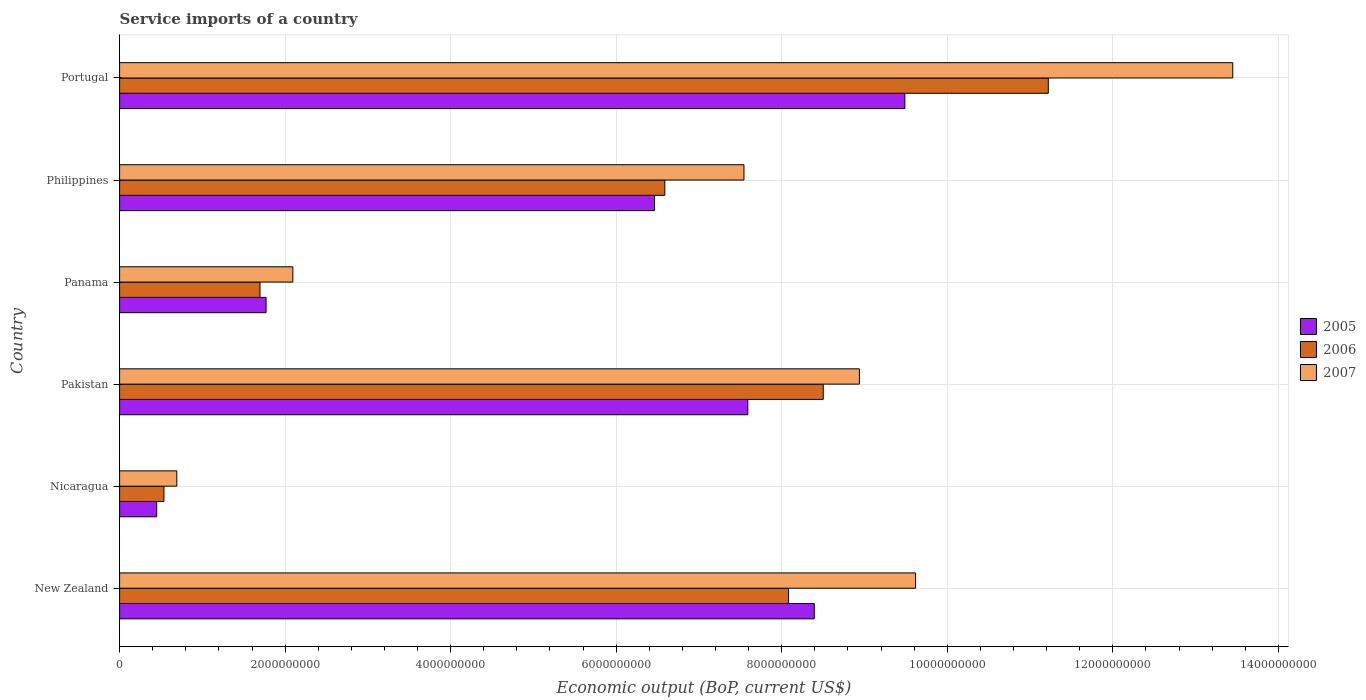How many different coloured bars are there?
Provide a short and direct response. 3. Are the number of bars per tick equal to the number of legend labels?
Make the answer very short. Yes. How many bars are there on the 1st tick from the bottom?
Give a very brief answer. 3. What is the label of the 4th group of bars from the top?
Offer a terse response. Pakistan. What is the service imports in 2006 in New Zealand?
Offer a terse response. 8.08e+09. Across all countries, what is the maximum service imports in 2006?
Provide a succinct answer. 1.12e+1. Across all countries, what is the minimum service imports in 2005?
Offer a terse response. 4.48e+08. In which country was the service imports in 2007 maximum?
Provide a short and direct response. Portugal. In which country was the service imports in 2005 minimum?
Ensure brevity in your answer.  Nicaragua. What is the total service imports in 2007 in the graph?
Keep it short and to the point. 4.23e+1. What is the difference between the service imports in 2007 in Nicaragua and that in Philippines?
Offer a terse response. -6.85e+09. What is the difference between the service imports in 2005 in New Zealand and the service imports in 2006 in Philippines?
Your response must be concise. 1.81e+09. What is the average service imports in 2005 per country?
Your response must be concise. 5.69e+09. What is the difference between the service imports in 2006 and service imports in 2007 in Pakistan?
Keep it short and to the point. -4.37e+08. In how many countries, is the service imports in 2007 greater than 7600000000 US$?
Give a very brief answer. 3. What is the ratio of the service imports in 2007 in Nicaragua to that in Philippines?
Your answer should be very brief. 0.09. Is the difference between the service imports in 2006 in Pakistan and Panama greater than the difference between the service imports in 2007 in Pakistan and Panama?
Your response must be concise. No. What is the difference between the highest and the second highest service imports in 2006?
Make the answer very short. 2.72e+09. What is the difference between the highest and the lowest service imports in 2006?
Offer a very short reply. 1.07e+1. In how many countries, is the service imports in 2007 greater than the average service imports in 2007 taken over all countries?
Your response must be concise. 4. Is the sum of the service imports in 2006 in Nicaragua and Philippines greater than the maximum service imports in 2007 across all countries?
Offer a very short reply. No. What does the 2nd bar from the top in Panama represents?
Keep it short and to the point. 2006. What does the 2nd bar from the bottom in New Zealand represents?
Make the answer very short. 2006. Is it the case that in every country, the sum of the service imports in 2006 and service imports in 2005 is greater than the service imports in 2007?
Provide a short and direct response. Yes. How many bars are there?
Provide a short and direct response. 18. Are all the bars in the graph horizontal?
Your response must be concise. Yes. What is the difference between two consecutive major ticks on the X-axis?
Your answer should be very brief. 2.00e+09. Are the values on the major ticks of X-axis written in scientific E-notation?
Your response must be concise. No. Does the graph contain any zero values?
Make the answer very short. No. How are the legend labels stacked?
Give a very brief answer. Vertical. What is the title of the graph?
Keep it short and to the point. Service imports of a country. Does "2008" appear as one of the legend labels in the graph?
Your answer should be very brief. No. What is the label or title of the X-axis?
Offer a very short reply. Economic output (BoP, current US$). What is the label or title of the Y-axis?
Your response must be concise. Country. What is the Economic output (BoP, current US$) in 2005 in New Zealand?
Your response must be concise. 8.39e+09. What is the Economic output (BoP, current US$) of 2006 in New Zealand?
Give a very brief answer. 8.08e+09. What is the Economic output (BoP, current US$) in 2007 in New Zealand?
Your answer should be very brief. 9.62e+09. What is the Economic output (BoP, current US$) in 2005 in Nicaragua?
Provide a succinct answer. 4.48e+08. What is the Economic output (BoP, current US$) in 2006 in Nicaragua?
Your answer should be compact. 5.36e+08. What is the Economic output (BoP, current US$) of 2007 in Nicaragua?
Provide a succinct answer. 6.91e+08. What is the Economic output (BoP, current US$) of 2005 in Pakistan?
Provide a succinct answer. 7.59e+09. What is the Economic output (BoP, current US$) in 2006 in Pakistan?
Ensure brevity in your answer.  8.50e+09. What is the Economic output (BoP, current US$) in 2007 in Pakistan?
Your response must be concise. 8.94e+09. What is the Economic output (BoP, current US$) in 2005 in Panama?
Your answer should be very brief. 1.77e+09. What is the Economic output (BoP, current US$) of 2006 in Panama?
Ensure brevity in your answer.  1.70e+09. What is the Economic output (BoP, current US$) in 2007 in Panama?
Make the answer very short. 2.09e+09. What is the Economic output (BoP, current US$) of 2005 in Philippines?
Your answer should be compact. 6.46e+09. What is the Economic output (BoP, current US$) of 2006 in Philippines?
Give a very brief answer. 6.59e+09. What is the Economic output (BoP, current US$) of 2007 in Philippines?
Provide a short and direct response. 7.54e+09. What is the Economic output (BoP, current US$) in 2005 in Portugal?
Offer a very short reply. 9.49e+09. What is the Economic output (BoP, current US$) of 2006 in Portugal?
Your response must be concise. 1.12e+1. What is the Economic output (BoP, current US$) of 2007 in Portugal?
Provide a succinct answer. 1.34e+1. Across all countries, what is the maximum Economic output (BoP, current US$) of 2005?
Give a very brief answer. 9.49e+09. Across all countries, what is the maximum Economic output (BoP, current US$) of 2006?
Provide a short and direct response. 1.12e+1. Across all countries, what is the maximum Economic output (BoP, current US$) of 2007?
Offer a terse response. 1.34e+1. Across all countries, what is the minimum Economic output (BoP, current US$) in 2005?
Offer a very short reply. 4.48e+08. Across all countries, what is the minimum Economic output (BoP, current US$) of 2006?
Provide a succinct answer. 5.36e+08. Across all countries, what is the minimum Economic output (BoP, current US$) of 2007?
Ensure brevity in your answer.  6.91e+08. What is the total Economic output (BoP, current US$) of 2005 in the graph?
Your answer should be very brief. 3.42e+1. What is the total Economic output (BoP, current US$) in 2006 in the graph?
Your response must be concise. 3.66e+1. What is the total Economic output (BoP, current US$) of 2007 in the graph?
Your answer should be very brief. 4.23e+1. What is the difference between the Economic output (BoP, current US$) in 2005 in New Zealand and that in Nicaragua?
Your answer should be compact. 7.94e+09. What is the difference between the Economic output (BoP, current US$) of 2006 in New Zealand and that in Nicaragua?
Make the answer very short. 7.55e+09. What is the difference between the Economic output (BoP, current US$) in 2007 in New Zealand and that in Nicaragua?
Give a very brief answer. 8.93e+09. What is the difference between the Economic output (BoP, current US$) in 2005 in New Zealand and that in Pakistan?
Your answer should be very brief. 8.03e+08. What is the difference between the Economic output (BoP, current US$) in 2006 in New Zealand and that in Pakistan?
Make the answer very short. -4.19e+08. What is the difference between the Economic output (BoP, current US$) in 2007 in New Zealand and that in Pakistan?
Give a very brief answer. 6.78e+08. What is the difference between the Economic output (BoP, current US$) in 2005 in New Zealand and that in Panama?
Give a very brief answer. 6.62e+09. What is the difference between the Economic output (BoP, current US$) in 2006 in New Zealand and that in Panama?
Offer a very short reply. 6.39e+09. What is the difference between the Economic output (BoP, current US$) in 2007 in New Zealand and that in Panama?
Your answer should be very brief. 7.52e+09. What is the difference between the Economic output (BoP, current US$) of 2005 in New Zealand and that in Philippines?
Offer a very short reply. 1.93e+09. What is the difference between the Economic output (BoP, current US$) of 2006 in New Zealand and that in Philippines?
Make the answer very short. 1.49e+09. What is the difference between the Economic output (BoP, current US$) of 2007 in New Zealand and that in Philippines?
Provide a short and direct response. 2.07e+09. What is the difference between the Economic output (BoP, current US$) in 2005 in New Zealand and that in Portugal?
Provide a short and direct response. -1.09e+09. What is the difference between the Economic output (BoP, current US$) of 2006 in New Zealand and that in Portugal?
Give a very brief answer. -3.14e+09. What is the difference between the Economic output (BoP, current US$) of 2007 in New Zealand and that in Portugal?
Your response must be concise. -3.83e+09. What is the difference between the Economic output (BoP, current US$) of 2005 in Nicaragua and that in Pakistan?
Ensure brevity in your answer.  -7.14e+09. What is the difference between the Economic output (BoP, current US$) of 2006 in Nicaragua and that in Pakistan?
Make the answer very short. -7.97e+09. What is the difference between the Economic output (BoP, current US$) in 2007 in Nicaragua and that in Pakistan?
Offer a very short reply. -8.25e+09. What is the difference between the Economic output (BoP, current US$) in 2005 in Nicaragua and that in Panama?
Provide a short and direct response. -1.32e+09. What is the difference between the Economic output (BoP, current US$) in 2006 in Nicaragua and that in Panama?
Offer a terse response. -1.16e+09. What is the difference between the Economic output (BoP, current US$) in 2007 in Nicaragua and that in Panama?
Make the answer very short. -1.40e+09. What is the difference between the Economic output (BoP, current US$) of 2005 in Nicaragua and that in Philippines?
Your response must be concise. -6.02e+09. What is the difference between the Economic output (BoP, current US$) in 2006 in Nicaragua and that in Philippines?
Your response must be concise. -6.05e+09. What is the difference between the Economic output (BoP, current US$) of 2007 in Nicaragua and that in Philippines?
Make the answer very short. -6.85e+09. What is the difference between the Economic output (BoP, current US$) in 2005 in Nicaragua and that in Portugal?
Your response must be concise. -9.04e+09. What is the difference between the Economic output (BoP, current US$) of 2006 in Nicaragua and that in Portugal?
Make the answer very short. -1.07e+1. What is the difference between the Economic output (BoP, current US$) in 2007 in Nicaragua and that in Portugal?
Offer a very short reply. -1.28e+1. What is the difference between the Economic output (BoP, current US$) of 2005 in Pakistan and that in Panama?
Your answer should be very brief. 5.82e+09. What is the difference between the Economic output (BoP, current US$) in 2006 in Pakistan and that in Panama?
Offer a terse response. 6.81e+09. What is the difference between the Economic output (BoP, current US$) in 2007 in Pakistan and that in Panama?
Provide a short and direct response. 6.85e+09. What is the difference between the Economic output (BoP, current US$) in 2005 in Pakistan and that in Philippines?
Ensure brevity in your answer.  1.13e+09. What is the difference between the Economic output (BoP, current US$) in 2006 in Pakistan and that in Philippines?
Your response must be concise. 1.91e+09. What is the difference between the Economic output (BoP, current US$) of 2007 in Pakistan and that in Philippines?
Provide a succinct answer. 1.40e+09. What is the difference between the Economic output (BoP, current US$) in 2005 in Pakistan and that in Portugal?
Ensure brevity in your answer.  -1.90e+09. What is the difference between the Economic output (BoP, current US$) in 2006 in Pakistan and that in Portugal?
Give a very brief answer. -2.72e+09. What is the difference between the Economic output (BoP, current US$) in 2007 in Pakistan and that in Portugal?
Give a very brief answer. -4.51e+09. What is the difference between the Economic output (BoP, current US$) of 2005 in Panama and that in Philippines?
Keep it short and to the point. -4.69e+09. What is the difference between the Economic output (BoP, current US$) in 2006 in Panama and that in Philippines?
Give a very brief answer. -4.89e+09. What is the difference between the Economic output (BoP, current US$) of 2007 in Panama and that in Philippines?
Give a very brief answer. -5.45e+09. What is the difference between the Economic output (BoP, current US$) in 2005 in Panama and that in Portugal?
Offer a terse response. -7.72e+09. What is the difference between the Economic output (BoP, current US$) in 2006 in Panama and that in Portugal?
Ensure brevity in your answer.  -9.52e+09. What is the difference between the Economic output (BoP, current US$) in 2007 in Panama and that in Portugal?
Your answer should be very brief. -1.14e+1. What is the difference between the Economic output (BoP, current US$) of 2005 in Philippines and that in Portugal?
Your response must be concise. -3.02e+09. What is the difference between the Economic output (BoP, current US$) in 2006 in Philippines and that in Portugal?
Provide a short and direct response. -4.63e+09. What is the difference between the Economic output (BoP, current US$) of 2007 in Philippines and that in Portugal?
Ensure brevity in your answer.  -5.91e+09. What is the difference between the Economic output (BoP, current US$) in 2005 in New Zealand and the Economic output (BoP, current US$) in 2006 in Nicaragua?
Offer a very short reply. 7.86e+09. What is the difference between the Economic output (BoP, current US$) in 2005 in New Zealand and the Economic output (BoP, current US$) in 2007 in Nicaragua?
Provide a short and direct response. 7.70e+09. What is the difference between the Economic output (BoP, current US$) of 2006 in New Zealand and the Economic output (BoP, current US$) of 2007 in Nicaragua?
Offer a very short reply. 7.39e+09. What is the difference between the Economic output (BoP, current US$) of 2005 in New Zealand and the Economic output (BoP, current US$) of 2006 in Pakistan?
Your answer should be very brief. -1.09e+08. What is the difference between the Economic output (BoP, current US$) in 2005 in New Zealand and the Economic output (BoP, current US$) in 2007 in Pakistan?
Your response must be concise. -5.46e+08. What is the difference between the Economic output (BoP, current US$) in 2006 in New Zealand and the Economic output (BoP, current US$) in 2007 in Pakistan?
Offer a terse response. -8.56e+08. What is the difference between the Economic output (BoP, current US$) of 2005 in New Zealand and the Economic output (BoP, current US$) of 2006 in Panama?
Provide a short and direct response. 6.70e+09. What is the difference between the Economic output (BoP, current US$) in 2005 in New Zealand and the Economic output (BoP, current US$) in 2007 in Panama?
Provide a succinct answer. 6.30e+09. What is the difference between the Economic output (BoP, current US$) of 2006 in New Zealand and the Economic output (BoP, current US$) of 2007 in Panama?
Keep it short and to the point. 5.99e+09. What is the difference between the Economic output (BoP, current US$) in 2005 in New Zealand and the Economic output (BoP, current US$) in 2006 in Philippines?
Your response must be concise. 1.81e+09. What is the difference between the Economic output (BoP, current US$) in 2005 in New Zealand and the Economic output (BoP, current US$) in 2007 in Philippines?
Your answer should be compact. 8.49e+08. What is the difference between the Economic output (BoP, current US$) of 2006 in New Zealand and the Economic output (BoP, current US$) of 2007 in Philippines?
Keep it short and to the point. 5.39e+08. What is the difference between the Economic output (BoP, current US$) in 2005 in New Zealand and the Economic output (BoP, current US$) in 2006 in Portugal?
Ensure brevity in your answer.  -2.83e+09. What is the difference between the Economic output (BoP, current US$) in 2005 in New Zealand and the Economic output (BoP, current US$) in 2007 in Portugal?
Keep it short and to the point. -5.06e+09. What is the difference between the Economic output (BoP, current US$) in 2006 in New Zealand and the Economic output (BoP, current US$) in 2007 in Portugal?
Make the answer very short. -5.37e+09. What is the difference between the Economic output (BoP, current US$) of 2005 in Nicaragua and the Economic output (BoP, current US$) of 2006 in Pakistan?
Make the answer very short. -8.05e+09. What is the difference between the Economic output (BoP, current US$) in 2005 in Nicaragua and the Economic output (BoP, current US$) in 2007 in Pakistan?
Ensure brevity in your answer.  -8.49e+09. What is the difference between the Economic output (BoP, current US$) in 2006 in Nicaragua and the Economic output (BoP, current US$) in 2007 in Pakistan?
Give a very brief answer. -8.40e+09. What is the difference between the Economic output (BoP, current US$) in 2005 in Nicaragua and the Economic output (BoP, current US$) in 2006 in Panama?
Your answer should be very brief. -1.25e+09. What is the difference between the Economic output (BoP, current US$) of 2005 in Nicaragua and the Economic output (BoP, current US$) of 2007 in Panama?
Make the answer very short. -1.64e+09. What is the difference between the Economic output (BoP, current US$) of 2006 in Nicaragua and the Economic output (BoP, current US$) of 2007 in Panama?
Offer a very short reply. -1.56e+09. What is the difference between the Economic output (BoP, current US$) in 2005 in Nicaragua and the Economic output (BoP, current US$) in 2006 in Philippines?
Your answer should be very brief. -6.14e+09. What is the difference between the Economic output (BoP, current US$) in 2005 in Nicaragua and the Economic output (BoP, current US$) in 2007 in Philippines?
Make the answer very short. -7.10e+09. What is the difference between the Economic output (BoP, current US$) in 2006 in Nicaragua and the Economic output (BoP, current US$) in 2007 in Philippines?
Your answer should be compact. -7.01e+09. What is the difference between the Economic output (BoP, current US$) of 2005 in Nicaragua and the Economic output (BoP, current US$) of 2006 in Portugal?
Your answer should be very brief. -1.08e+1. What is the difference between the Economic output (BoP, current US$) in 2005 in Nicaragua and the Economic output (BoP, current US$) in 2007 in Portugal?
Ensure brevity in your answer.  -1.30e+1. What is the difference between the Economic output (BoP, current US$) in 2006 in Nicaragua and the Economic output (BoP, current US$) in 2007 in Portugal?
Give a very brief answer. -1.29e+1. What is the difference between the Economic output (BoP, current US$) of 2005 in Pakistan and the Economic output (BoP, current US$) of 2006 in Panama?
Ensure brevity in your answer.  5.89e+09. What is the difference between the Economic output (BoP, current US$) in 2005 in Pakistan and the Economic output (BoP, current US$) in 2007 in Panama?
Ensure brevity in your answer.  5.50e+09. What is the difference between the Economic output (BoP, current US$) of 2006 in Pakistan and the Economic output (BoP, current US$) of 2007 in Panama?
Make the answer very short. 6.41e+09. What is the difference between the Economic output (BoP, current US$) of 2005 in Pakistan and the Economic output (BoP, current US$) of 2006 in Philippines?
Your answer should be very brief. 1.00e+09. What is the difference between the Economic output (BoP, current US$) of 2005 in Pakistan and the Economic output (BoP, current US$) of 2007 in Philippines?
Your answer should be very brief. 4.63e+07. What is the difference between the Economic output (BoP, current US$) of 2006 in Pakistan and the Economic output (BoP, current US$) of 2007 in Philippines?
Offer a very short reply. 9.58e+08. What is the difference between the Economic output (BoP, current US$) in 2005 in Pakistan and the Economic output (BoP, current US$) in 2006 in Portugal?
Your answer should be compact. -3.63e+09. What is the difference between the Economic output (BoP, current US$) of 2005 in Pakistan and the Economic output (BoP, current US$) of 2007 in Portugal?
Ensure brevity in your answer.  -5.86e+09. What is the difference between the Economic output (BoP, current US$) in 2006 in Pakistan and the Economic output (BoP, current US$) in 2007 in Portugal?
Keep it short and to the point. -4.95e+09. What is the difference between the Economic output (BoP, current US$) of 2005 in Panama and the Economic output (BoP, current US$) of 2006 in Philippines?
Provide a short and direct response. -4.82e+09. What is the difference between the Economic output (BoP, current US$) in 2005 in Panama and the Economic output (BoP, current US$) in 2007 in Philippines?
Keep it short and to the point. -5.77e+09. What is the difference between the Economic output (BoP, current US$) in 2006 in Panama and the Economic output (BoP, current US$) in 2007 in Philippines?
Your answer should be compact. -5.85e+09. What is the difference between the Economic output (BoP, current US$) of 2005 in Panama and the Economic output (BoP, current US$) of 2006 in Portugal?
Make the answer very short. -9.45e+09. What is the difference between the Economic output (BoP, current US$) in 2005 in Panama and the Economic output (BoP, current US$) in 2007 in Portugal?
Keep it short and to the point. -1.17e+1. What is the difference between the Economic output (BoP, current US$) of 2006 in Panama and the Economic output (BoP, current US$) of 2007 in Portugal?
Provide a short and direct response. -1.18e+1. What is the difference between the Economic output (BoP, current US$) of 2005 in Philippines and the Economic output (BoP, current US$) of 2006 in Portugal?
Keep it short and to the point. -4.76e+09. What is the difference between the Economic output (BoP, current US$) of 2005 in Philippines and the Economic output (BoP, current US$) of 2007 in Portugal?
Offer a terse response. -6.99e+09. What is the difference between the Economic output (BoP, current US$) in 2006 in Philippines and the Economic output (BoP, current US$) in 2007 in Portugal?
Your answer should be very brief. -6.86e+09. What is the average Economic output (BoP, current US$) of 2005 per country?
Keep it short and to the point. 5.69e+09. What is the average Economic output (BoP, current US$) in 2006 per country?
Your answer should be very brief. 6.10e+09. What is the average Economic output (BoP, current US$) in 2007 per country?
Ensure brevity in your answer.  7.06e+09. What is the difference between the Economic output (BoP, current US$) of 2005 and Economic output (BoP, current US$) of 2006 in New Zealand?
Keep it short and to the point. 3.11e+08. What is the difference between the Economic output (BoP, current US$) in 2005 and Economic output (BoP, current US$) in 2007 in New Zealand?
Provide a succinct answer. -1.22e+09. What is the difference between the Economic output (BoP, current US$) of 2006 and Economic output (BoP, current US$) of 2007 in New Zealand?
Your response must be concise. -1.53e+09. What is the difference between the Economic output (BoP, current US$) of 2005 and Economic output (BoP, current US$) of 2006 in Nicaragua?
Offer a terse response. -8.75e+07. What is the difference between the Economic output (BoP, current US$) in 2005 and Economic output (BoP, current US$) in 2007 in Nicaragua?
Keep it short and to the point. -2.43e+08. What is the difference between the Economic output (BoP, current US$) in 2006 and Economic output (BoP, current US$) in 2007 in Nicaragua?
Ensure brevity in your answer.  -1.56e+08. What is the difference between the Economic output (BoP, current US$) of 2005 and Economic output (BoP, current US$) of 2006 in Pakistan?
Offer a very short reply. -9.11e+08. What is the difference between the Economic output (BoP, current US$) in 2005 and Economic output (BoP, current US$) in 2007 in Pakistan?
Provide a succinct answer. -1.35e+09. What is the difference between the Economic output (BoP, current US$) of 2006 and Economic output (BoP, current US$) of 2007 in Pakistan?
Offer a terse response. -4.37e+08. What is the difference between the Economic output (BoP, current US$) in 2005 and Economic output (BoP, current US$) in 2006 in Panama?
Offer a terse response. 7.32e+07. What is the difference between the Economic output (BoP, current US$) in 2005 and Economic output (BoP, current US$) in 2007 in Panama?
Offer a terse response. -3.24e+08. What is the difference between the Economic output (BoP, current US$) of 2006 and Economic output (BoP, current US$) of 2007 in Panama?
Provide a succinct answer. -3.97e+08. What is the difference between the Economic output (BoP, current US$) of 2005 and Economic output (BoP, current US$) of 2006 in Philippines?
Your answer should be very brief. -1.24e+08. What is the difference between the Economic output (BoP, current US$) in 2005 and Economic output (BoP, current US$) in 2007 in Philippines?
Offer a very short reply. -1.08e+09. What is the difference between the Economic output (BoP, current US$) in 2006 and Economic output (BoP, current US$) in 2007 in Philippines?
Your answer should be compact. -9.56e+08. What is the difference between the Economic output (BoP, current US$) of 2005 and Economic output (BoP, current US$) of 2006 in Portugal?
Offer a very short reply. -1.73e+09. What is the difference between the Economic output (BoP, current US$) of 2005 and Economic output (BoP, current US$) of 2007 in Portugal?
Ensure brevity in your answer.  -3.96e+09. What is the difference between the Economic output (BoP, current US$) of 2006 and Economic output (BoP, current US$) of 2007 in Portugal?
Keep it short and to the point. -2.23e+09. What is the ratio of the Economic output (BoP, current US$) in 2005 in New Zealand to that in Nicaragua?
Provide a succinct answer. 18.73. What is the ratio of the Economic output (BoP, current US$) in 2006 in New Zealand to that in Nicaragua?
Offer a very short reply. 15.09. What is the ratio of the Economic output (BoP, current US$) in 2007 in New Zealand to that in Nicaragua?
Ensure brevity in your answer.  13.91. What is the ratio of the Economic output (BoP, current US$) of 2005 in New Zealand to that in Pakistan?
Offer a very short reply. 1.11. What is the ratio of the Economic output (BoP, current US$) in 2006 in New Zealand to that in Pakistan?
Offer a very short reply. 0.95. What is the ratio of the Economic output (BoP, current US$) of 2007 in New Zealand to that in Pakistan?
Give a very brief answer. 1.08. What is the ratio of the Economic output (BoP, current US$) of 2005 in New Zealand to that in Panama?
Your response must be concise. 4.74. What is the ratio of the Economic output (BoP, current US$) of 2006 in New Zealand to that in Panama?
Offer a terse response. 4.76. What is the ratio of the Economic output (BoP, current US$) of 2007 in New Zealand to that in Panama?
Provide a short and direct response. 4.59. What is the ratio of the Economic output (BoP, current US$) of 2005 in New Zealand to that in Philippines?
Provide a succinct answer. 1.3. What is the ratio of the Economic output (BoP, current US$) in 2006 in New Zealand to that in Philippines?
Your answer should be very brief. 1.23. What is the ratio of the Economic output (BoP, current US$) of 2007 in New Zealand to that in Philippines?
Provide a short and direct response. 1.27. What is the ratio of the Economic output (BoP, current US$) in 2005 in New Zealand to that in Portugal?
Ensure brevity in your answer.  0.88. What is the ratio of the Economic output (BoP, current US$) of 2006 in New Zealand to that in Portugal?
Provide a succinct answer. 0.72. What is the ratio of the Economic output (BoP, current US$) of 2007 in New Zealand to that in Portugal?
Provide a short and direct response. 0.72. What is the ratio of the Economic output (BoP, current US$) in 2005 in Nicaragua to that in Pakistan?
Offer a terse response. 0.06. What is the ratio of the Economic output (BoP, current US$) of 2006 in Nicaragua to that in Pakistan?
Provide a succinct answer. 0.06. What is the ratio of the Economic output (BoP, current US$) of 2007 in Nicaragua to that in Pakistan?
Make the answer very short. 0.08. What is the ratio of the Economic output (BoP, current US$) in 2005 in Nicaragua to that in Panama?
Your response must be concise. 0.25. What is the ratio of the Economic output (BoP, current US$) in 2006 in Nicaragua to that in Panama?
Your response must be concise. 0.32. What is the ratio of the Economic output (BoP, current US$) of 2007 in Nicaragua to that in Panama?
Your answer should be compact. 0.33. What is the ratio of the Economic output (BoP, current US$) in 2005 in Nicaragua to that in Philippines?
Give a very brief answer. 0.07. What is the ratio of the Economic output (BoP, current US$) of 2006 in Nicaragua to that in Philippines?
Offer a very short reply. 0.08. What is the ratio of the Economic output (BoP, current US$) of 2007 in Nicaragua to that in Philippines?
Provide a succinct answer. 0.09. What is the ratio of the Economic output (BoP, current US$) in 2005 in Nicaragua to that in Portugal?
Keep it short and to the point. 0.05. What is the ratio of the Economic output (BoP, current US$) in 2006 in Nicaragua to that in Portugal?
Make the answer very short. 0.05. What is the ratio of the Economic output (BoP, current US$) of 2007 in Nicaragua to that in Portugal?
Provide a succinct answer. 0.05. What is the ratio of the Economic output (BoP, current US$) in 2005 in Pakistan to that in Panama?
Make the answer very short. 4.29. What is the ratio of the Economic output (BoP, current US$) in 2006 in Pakistan to that in Panama?
Your answer should be compact. 5.01. What is the ratio of the Economic output (BoP, current US$) in 2007 in Pakistan to that in Panama?
Provide a succinct answer. 4.27. What is the ratio of the Economic output (BoP, current US$) in 2005 in Pakistan to that in Philippines?
Provide a short and direct response. 1.17. What is the ratio of the Economic output (BoP, current US$) in 2006 in Pakistan to that in Philippines?
Ensure brevity in your answer.  1.29. What is the ratio of the Economic output (BoP, current US$) in 2007 in Pakistan to that in Philippines?
Ensure brevity in your answer.  1.18. What is the ratio of the Economic output (BoP, current US$) of 2005 in Pakistan to that in Portugal?
Offer a terse response. 0.8. What is the ratio of the Economic output (BoP, current US$) in 2006 in Pakistan to that in Portugal?
Make the answer very short. 0.76. What is the ratio of the Economic output (BoP, current US$) of 2007 in Pakistan to that in Portugal?
Make the answer very short. 0.66. What is the ratio of the Economic output (BoP, current US$) in 2005 in Panama to that in Philippines?
Your answer should be compact. 0.27. What is the ratio of the Economic output (BoP, current US$) in 2006 in Panama to that in Philippines?
Your answer should be compact. 0.26. What is the ratio of the Economic output (BoP, current US$) in 2007 in Panama to that in Philippines?
Provide a succinct answer. 0.28. What is the ratio of the Economic output (BoP, current US$) of 2005 in Panama to that in Portugal?
Your response must be concise. 0.19. What is the ratio of the Economic output (BoP, current US$) of 2006 in Panama to that in Portugal?
Offer a very short reply. 0.15. What is the ratio of the Economic output (BoP, current US$) in 2007 in Panama to that in Portugal?
Give a very brief answer. 0.16. What is the ratio of the Economic output (BoP, current US$) in 2005 in Philippines to that in Portugal?
Ensure brevity in your answer.  0.68. What is the ratio of the Economic output (BoP, current US$) of 2006 in Philippines to that in Portugal?
Offer a terse response. 0.59. What is the ratio of the Economic output (BoP, current US$) in 2007 in Philippines to that in Portugal?
Keep it short and to the point. 0.56. What is the difference between the highest and the second highest Economic output (BoP, current US$) in 2005?
Make the answer very short. 1.09e+09. What is the difference between the highest and the second highest Economic output (BoP, current US$) in 2006?
Offer a terse response. 2.72e+09. What is the difference between the highest and the second highest Economic output (BoP, current US$) of 2007?
Your answer should be compact. 3.83e+09. What is the difference between the highest and the lowest Economic output (BoP, current US$) in 2005?
Provide a short and direct response. 9.04e+09. What is the difference between the highest and the lowest Economic output (BoP, current US$) of 2006?
Provide a succinct answer. 1.07e+1. What is the difference between the highest and the lowest Economic output (BoP, current US$) in 2007?
Your answer should be very brief. 1.28e+1. 